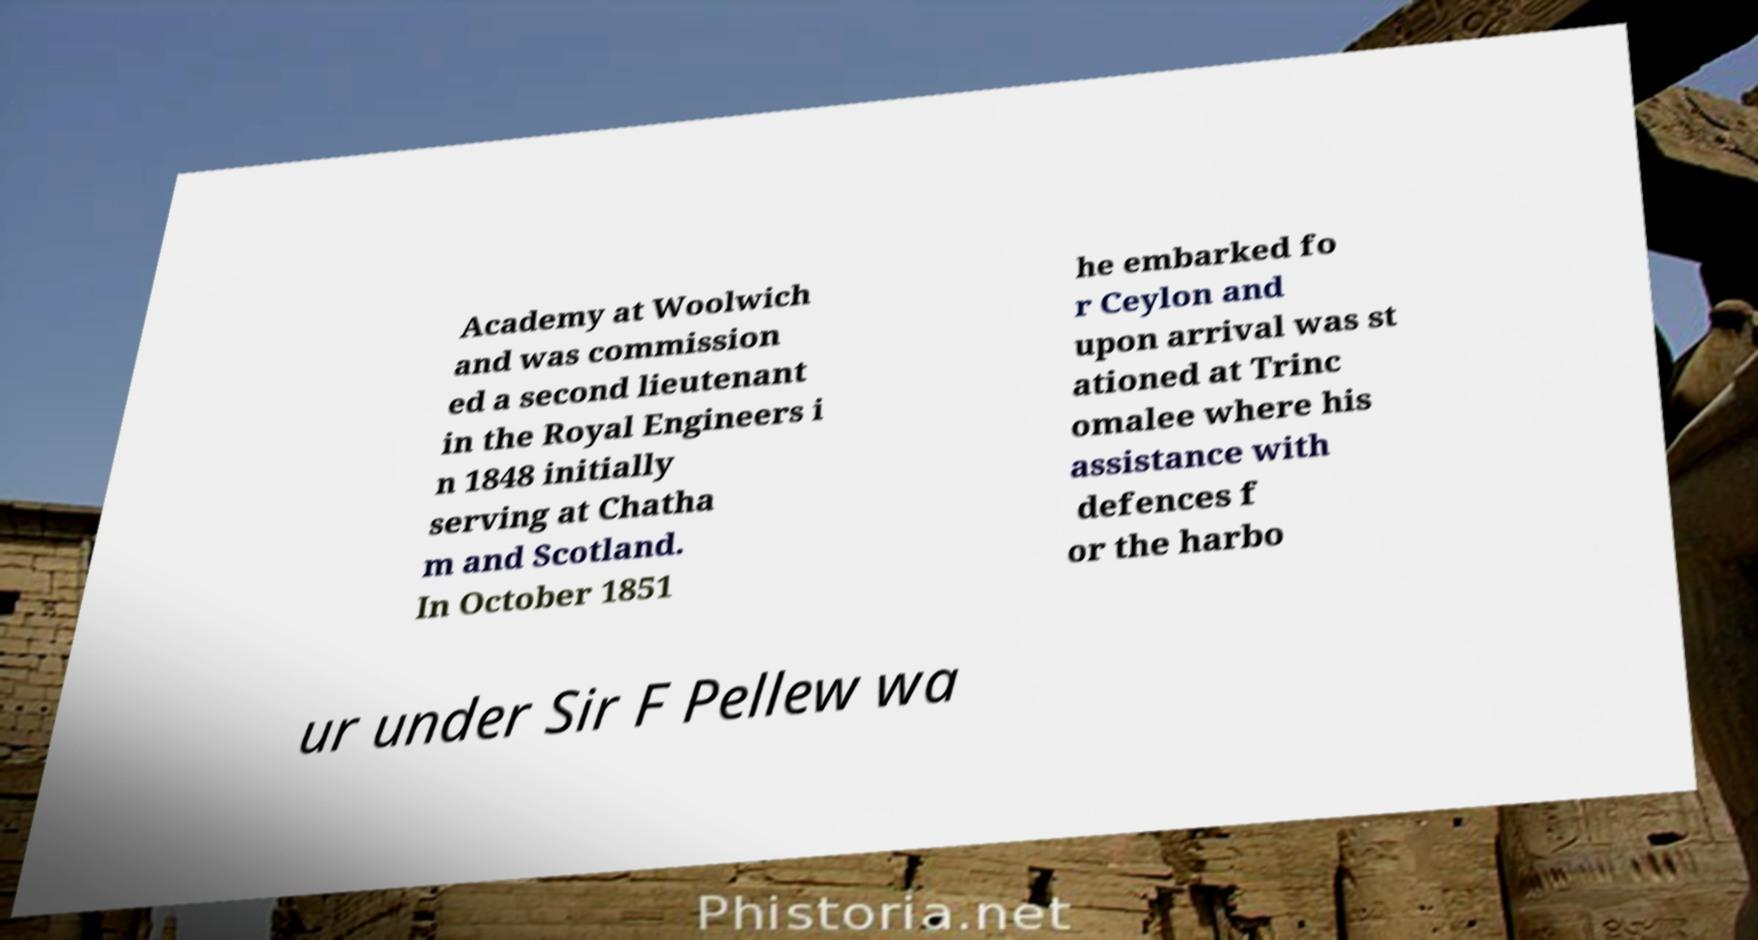Please read and relay the text visible in this image. What does it say? Academy at Woolwich and was commission ed a second lieutenant in the Royal Engineers i n 1848 initially serving at Chatha m and Scotland. In October 1851 he embarked fo r Ceylon and upon arrival was st ationed at Trinc omalee where his assistance with defences f or the harbo ur under Sir F Pellew wa 